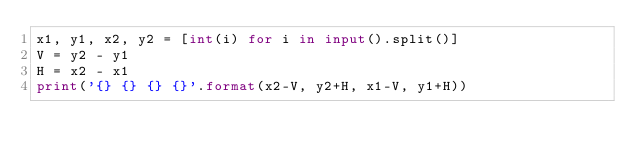Convert code to text. <code><loc_0><loc_0><loc_500><loc_500><_Python_>x1, y1, x2, y2 = [int(i) for i in input().split()]
V = y2 - y1
H = x2 - x1
print('{} {} {} {}'.format(x2-V, y2+H, x1-V, y1+H))</code> 